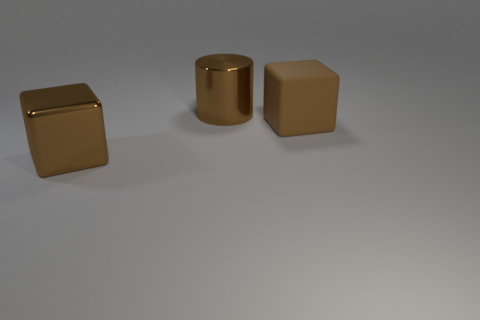What is the size of the object that is the same material as the brown cylinder?
Ensure brevity in your answer.  Large. What number of large metal spheres have the same color as the large cylinder?
Your answer should be compact. 0. Is the number of big shiny cylinders that are behind the large brown cylinder less than the number of large shiny cubes in front of the large brown metallic block?
Provide a short and direct response. No. There is a brown shiny object that is to the left of the big brown cylinder; does it have the same shape as the big rubber thing?
Offer a very short reply. Yes. Are there any other things that are made of the same material as the brown cylinder?
Provide a succinct answer. Yes. Are the big cube that is in front of the brown matte cube and the big brown cylinder made of the same material?
Your answer should be compact. Yes. The brown cube in front of the cube on the right side of the large brown cube that is in front of the big rubber object is made of what material?
Provide a succinct answer. Metal. How many other things are the same shape as the big rubber thing?
Keep it short and to the point. 1. What number of big brown matte blocks are behind the brown metal cube on the left side of the big block that is behind the brown metal block?
Your answer should be compact. 1. What number of big brown cubes are in front of the brown metallic object in front of the large rubber thing?
Provide a short and direct response. 0. 